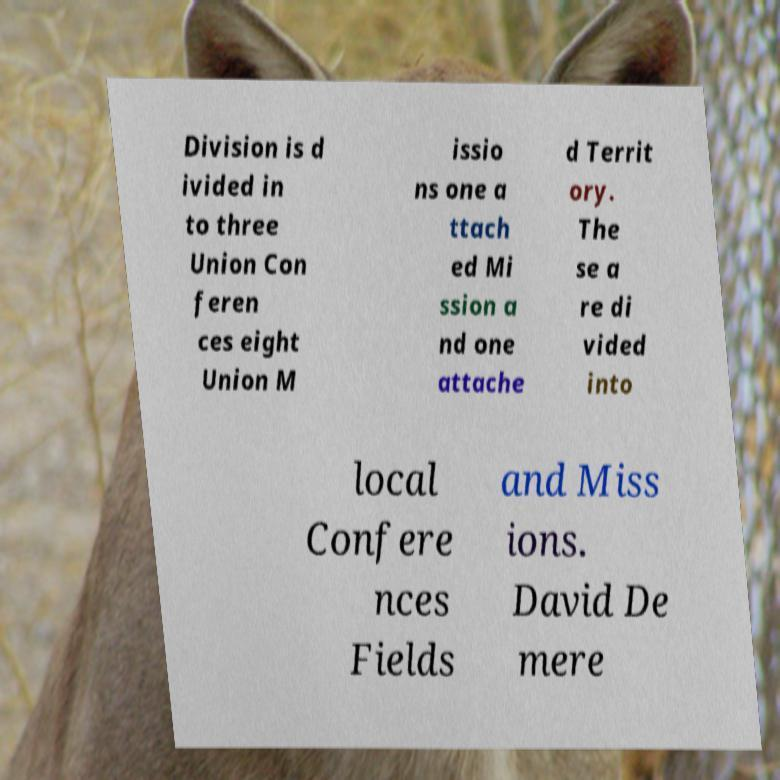For documentation purposes, I need the text within this image transcribed. Could you provide that? Division is d ivided in to three Union Con feren ces eight Union M issio ns one a ttach ed Mi ssion a nd one attache d Territ ory. The se a re di vided into local Confere nces Fields and Miss ions. David De mere 